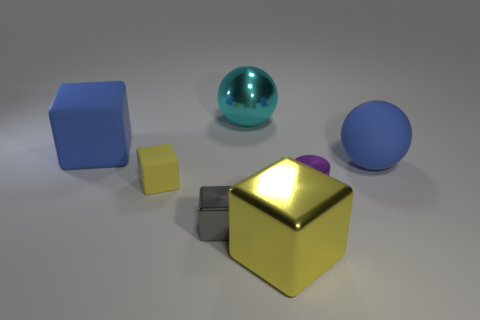Subtract all gray cubes. How many cubes are left? 3 Subtract all gray blocks. How many blocks are left? 3 Add 1 purple matte objects. How many objects exist? 8 Subtract all green cubes. Subtract all red balls. How many cubes are left? 4 Subtract all cylinders. How many objects are left? 6 Add 7 matte things. How many matte things exist? 10 Subtract 0 purple blocks. How many objects are left? 7 Subtract all big purple spheres. Subtract all cyan objects. How many objects are left? 6 Add 3 shiny spheres. How many shiny spheres are left? 4 